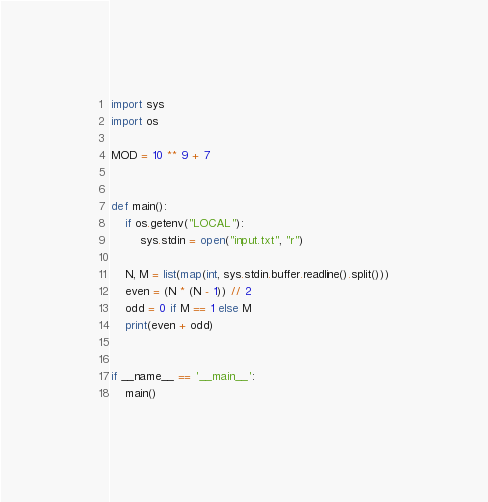Convert code to text. <code><loc_0><loc_0><loc_500><loc_500><_Python_>import sys
import os

MOD = 10 ** 9 + 7


def main():
    if os.getenv("LOCAL"):
        sys.stdin = open("input.txt", "r")

    N, M = list(map(int, sys.stdin.buffer.readline().split()))
    even = (N * (N - 1)) // 2
    odd = 0 if M == 1 else M
    print(even + odd)


if __name__ == '__main__':
    main()
</code> 